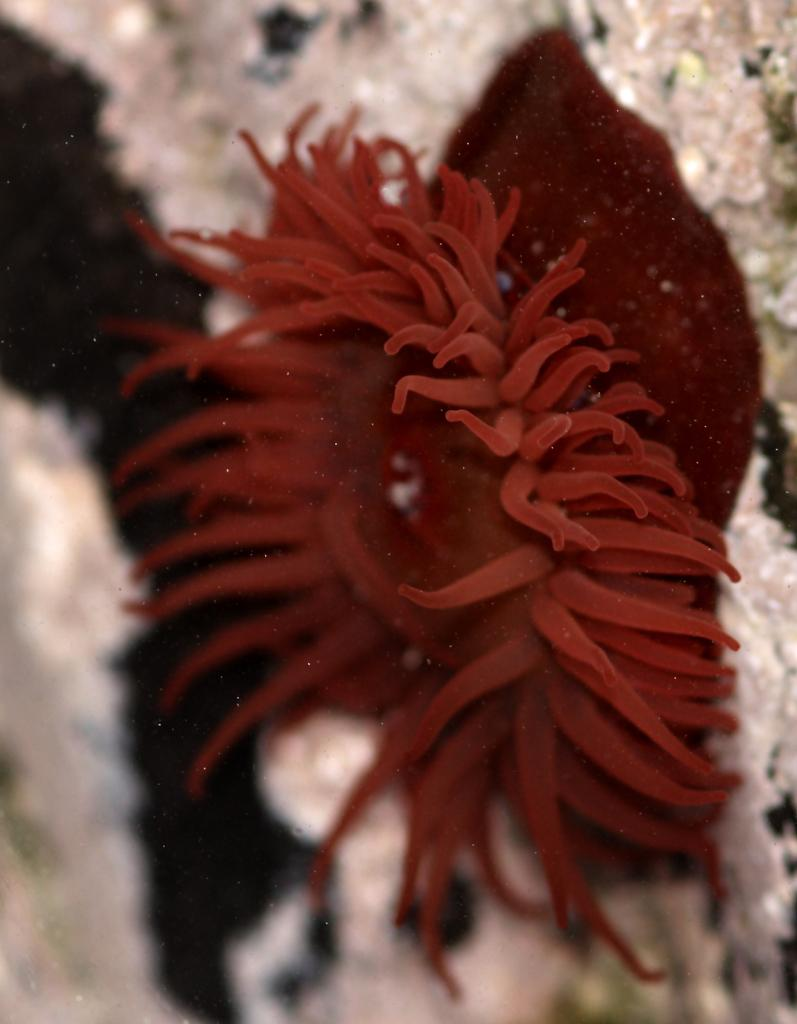What type of animal can be seen in the image? There is a sea creature in the image. Where is the sea creature located? The sea creature is sitting on coral stones. How many cats are sitting on the sofa in the image? There are no cats or sofa present in the image; it features a sea creature sitting on coral stones. 